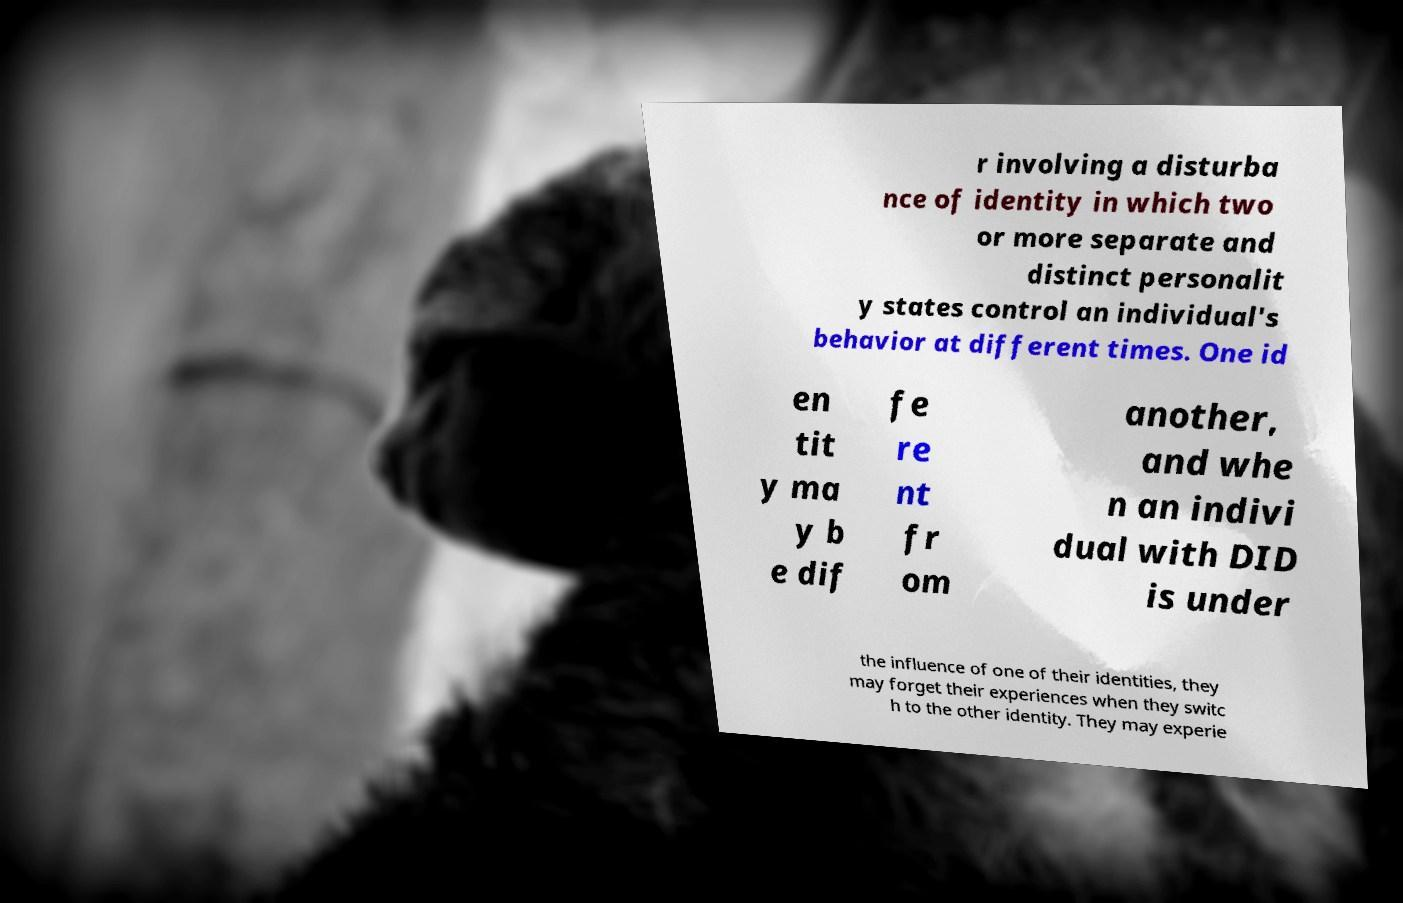Please identify and transcribe the text found in this image. r involving a disturba nce of identity in which two or more separate and distinct personalit y states control an individual's behavior at different times. One id en tit y ma y b e dif fe re nt fr om another, and whe n an indivi dual with DID is under the influence of one of their identities, they may forget their experiences when they switc h to the other identity. They may experie 